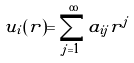Convert formula to latex. <formula><loc_0><loc_0><loc_500><loc_500>u _ { i } ( r ) = \sum _ { j = 1 } ^ { \infty } a _ { i j } r ^ { j }</formula> 